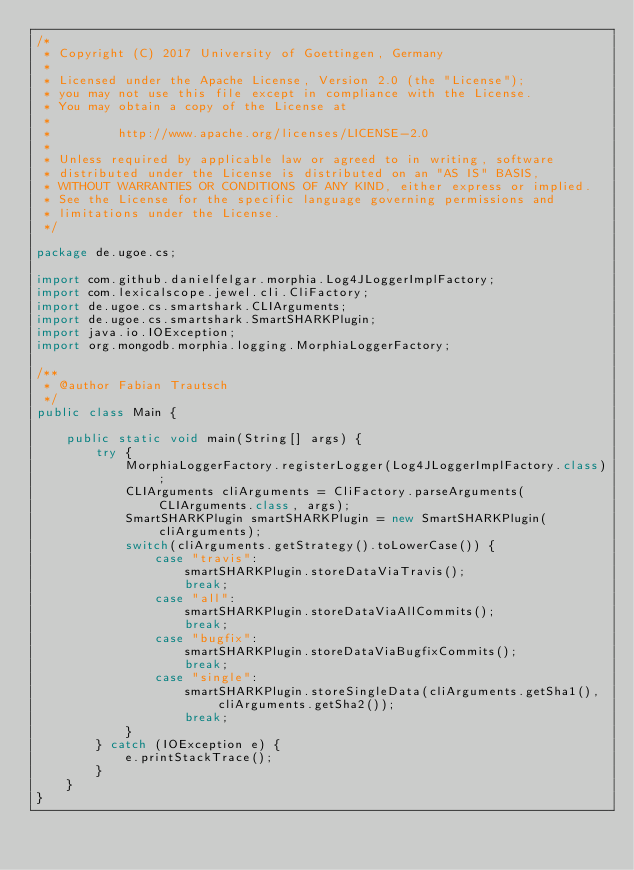<code> <loc_0><loc_0><loc_500><loc_500><_Java_>/*
 * Copyright (C) 2017 University of Goettingen, Germany
 *
 * Licensed under the Apache License, Version 2.0 (the "License");
 * you may not use this file except in compliance with the License.
 * You may obtain a copy of the License at
 *
 *         http://www.apache.org/licenses/LICENSE-2.0
 *
 * Unless required by applicable law or agreed to in writing, software
 * distributed under the License is distributed on an "AS IS" BASIS,
 * WITHOUT WARRANTIES OR CONDITIONS OF ANY KIND, either express or implied.
 * See the License for the specific language governing permissions and
 * limitations under the License.
 */

package de.ugoe.cs;

import com.github.danielfelgar.morphia.Log4JLoggerImplFactory;
import com.lexicalscope.jewel.cli.CliFactory;
import de.ugoe.cs.smartshark.CLIArguments;
import de.ugoe.cs.smartshark.SmartSHARKPlugin;
import java.io.IOException;
import org.mongodb.morphia.logging.MorphiaLoggerFactory;

/**
 * @author Fabian Trautsch
 */
public class Main {

    public static void main(String[] args) {
        try {
            MorphiaLoggerFactory.registerLogger(Log4JLoggerImplFactory.class);
            CLIArguments cliArguments = CliFactory.parseArguments(CLIArguments.class, args);
            SmartSHARKPlugin smartSHARKPlugin = new SmartSHARKPlugin(cliArguments);
            switch(cliArguments.getStrategy().toLowerCase()) {
                case "travis":
                    smartSHARKPlugin.storeDataViaTravis();
                    break;
                case "all":
                    smartSHARKPlugin.storeDataViaAllCommits();
                    break;
                case "bugfix":
                    smartSHARKPlugin.storeDataViaBugfixCommits();
                    break;
                case "single":
                    smartSHARKPlugin.storeSingleData(cliArguments.getSha1(), cliArguments.getSha2());
                    break;
            }
        } catch (IOException e) {
            e.printStackTrace();
        }
    }
}
</code> 